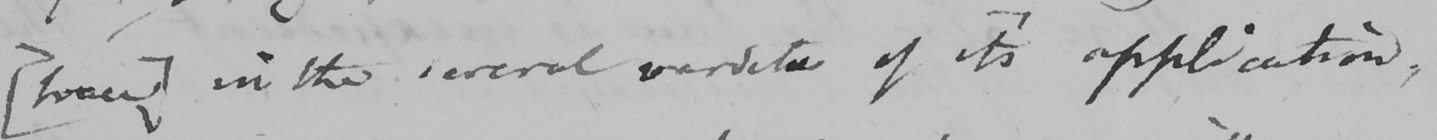Can you tell me what this handwritten text says? [  <gap/>  ]  in the several verdicts of it ' s application , 